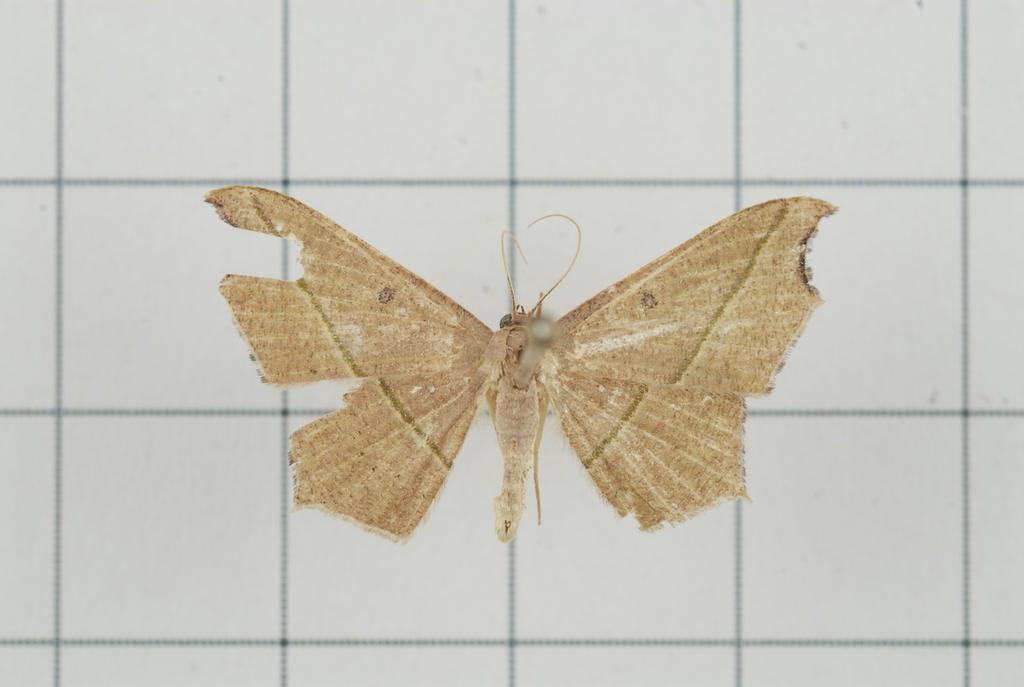What is the main subject of the image? There is a butterfly in the image. Where is the butterfly located? The butterfly is on the wall. What type of skirt is the butterfly wearing in the image? Butterflies do not wear skirts, as they are insects and do not have clothing. 